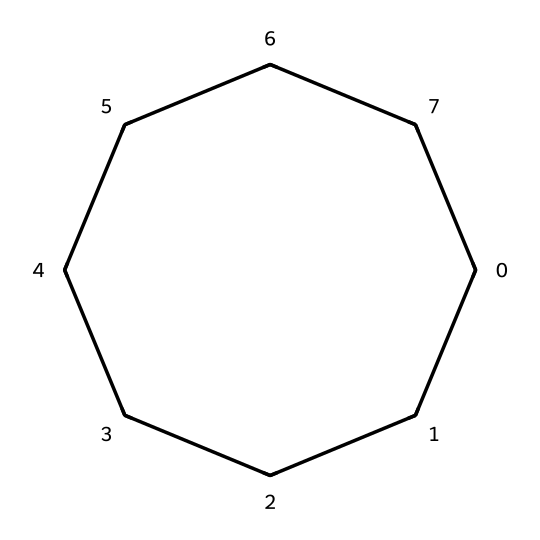how many carbon atoms are in cyclooctane? The SMILES representation shows the structure as C1CCCCCCC1, which indicates a cyclic structure with eight carbon atoms. Therefore, by counting the 'C' in the chemical structure, we see there are eight carbons in total.
Answer: eight what is the total number of hydrogen atoms in cyclooctane? Each carbon in cyclooctane is connected in a ring structure and typically forms two hydrogen atoms except for the junction points. For a cycloalkane, the formula is CnH2n. Here, n=8, so the total hydrogen atoms = 2 * 8 = 16.
Answer: sixteen is cyclooctane a saturated or unsaturated hydrocarbon? Cyclooctane contains only single C-C bonds as indicated by its saturated nature, which fits the definition of a saturated hydrocarbon. Therefore, it does not contain any double or triple bonds.
Answer: saturated what type of chemical structure is exhibited by cyclooctane? Cyclooctane exhibits a cyclic structure as its SMILES representation forms a loop (denoted by C1...C1), indicating it is a cyclic alkane.
Answer: cyclic does cyclooctane have geometric isomers? Cyclooctane does not have geometric isomers because it is a cyclic alkane where all carbon atoms are sp3 hybridized and possess single C-C bonds, preventing spatial variation in structure that would lead to isomers.
Answer: no what is the primary application of cyclooctane in the industry? Cyclooctane is primarily used as a component in industrial lubricants, where its properties help reduce friction and wear between surfaces.
Answer: lubricants what structural feature of cyclooctane defines it as a cycloalkane? The distinctive closed-loop structure of cyclooctane, represented in the SMILES by C1CCCCCCC1, identifies it as a cycloalkane. In cycloalkanes, carbon atoms are arranged in a ring, differentiating them from open-chain alkanes.
Answer: ring structure 